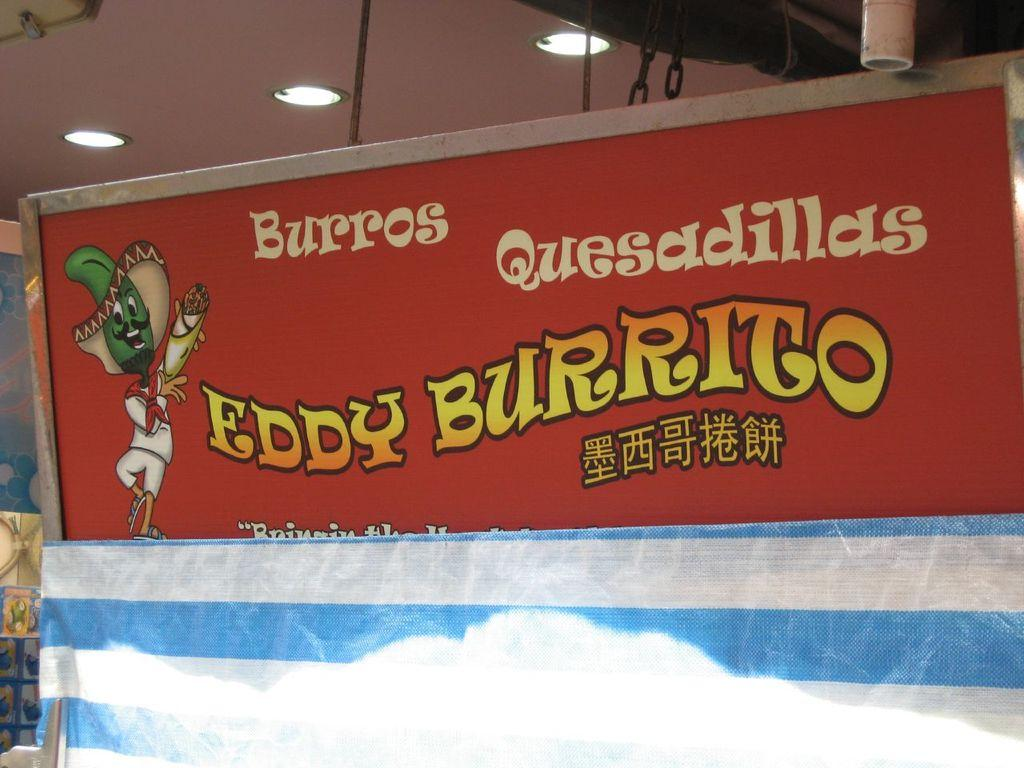Provide a one-sentence caption for the provided image. A banner for Burros Quesadillas from Eddy Burrito advertises the product. 